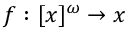<formula> <loc_0><loc_0><loc_500><loc_500>f \colon [ x ] ^ { \omega } \to x</formula> 